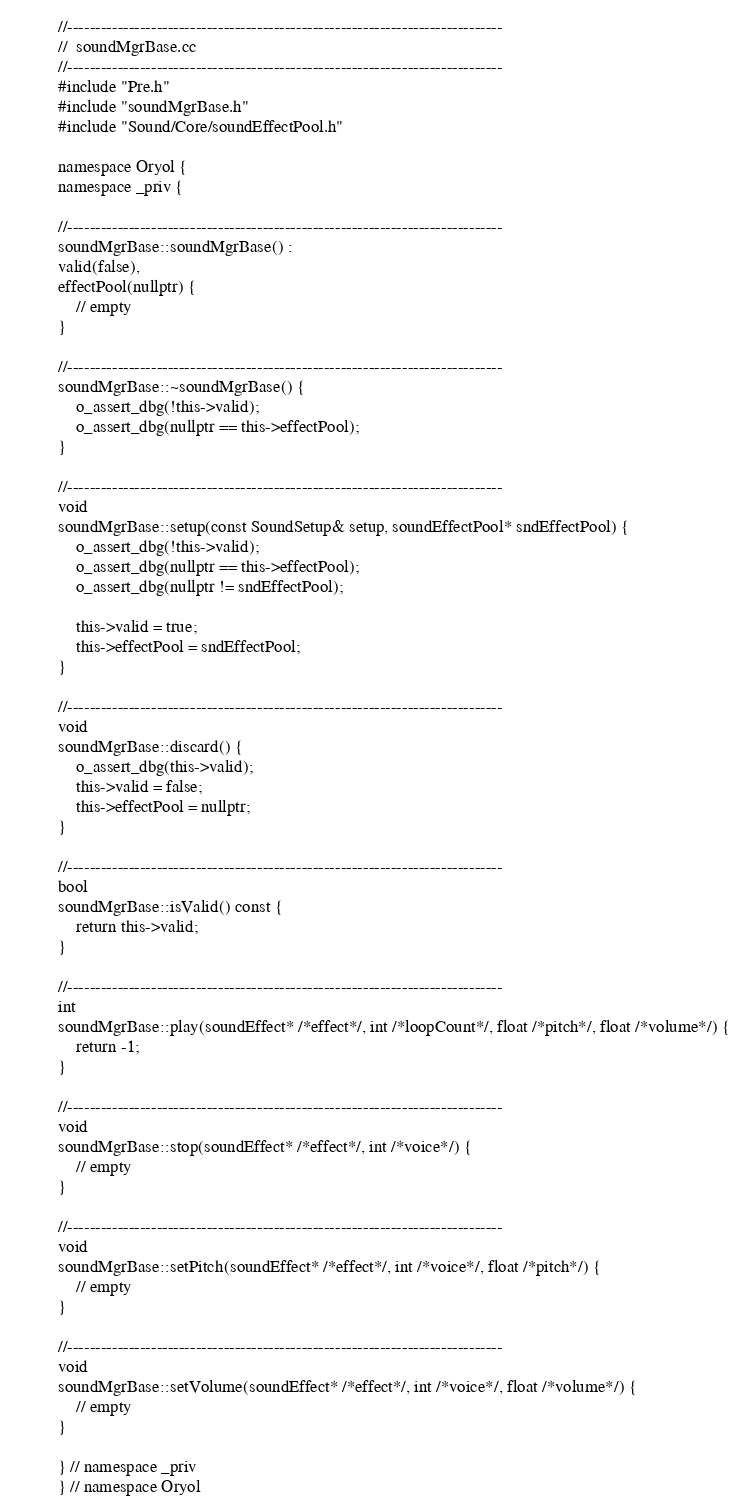Convert code to text. <code><loc_0><loc_0><loc_500><loc_500><_C++_>//------------------------------------------------------------------------------
//  soundMgrBase.cc
//------------------------------------------------------------------------------
#include "Pre.h"
#include "soundMgrBase.h"
#include "Sound/Core/soundEffectPool.h"

namespace Oryol {
namespace _priv {

//------------------------------------------------------------------------------
soundMgrBase::soundMgrBase() :
valid(false),
effectPool(nullptr) {
    // empty
}

//------------------------------------------------------------------------------
soundMgrBase::~soundMgrBase() {
    o_assert_dbg(!this->valid);
    o_assert_dbg(nullptr == this->effectPool);
}

//------------------------------------------------------------------------------
void
soundMgrBase::setup(const SoundSetup& setup, soundEffectPool* sndEffectPool) {
    o_assert_dbg(!this->valid);
    o_assert_dbg(nullptr == this->effectPool);
    o_assert_dbg(nullptr != sndEffectPool);

    this->valid = true;
    this->effectPool = sndEffectPool;
}

//------------------------------------------------------------------------------
void
soundMgrBase::discard() {
    o_assert_dbg(this->valid);
    this->valid = false;
    this->effectPool = nullptr;
}

//------------------------------------------------------------------------------
bool
soundMgrBase::isValid() const {
    return this->valid;
}

//------------------------------------------------------------------------------
int
soundMgrBase::play(soundEffect* /*effect*/, int /*loopCount*/, float /*pitch*/, float /*volume*/) {
    return -1;
}

//------------------------------------------------------------------------------
void
soundMgrBase::stop(soundEffect* /*effect*/, int /*voice*/) {
    // empty
}

//------------------------------------------------------------------------------
void
soundMgrBase::setPitch(soundEffect* /*effect*/, int /*voice*/, float /*pitch*/) {
    // empty
}

//------------------------------------------------------------------------------
void
soundMgrBase::setVolume(soundEffect* /*effect*/, int /*voice*/, float /*volume*/) {
    // empty
}

} // namespace _priv
} // namespace Oryol</code> 